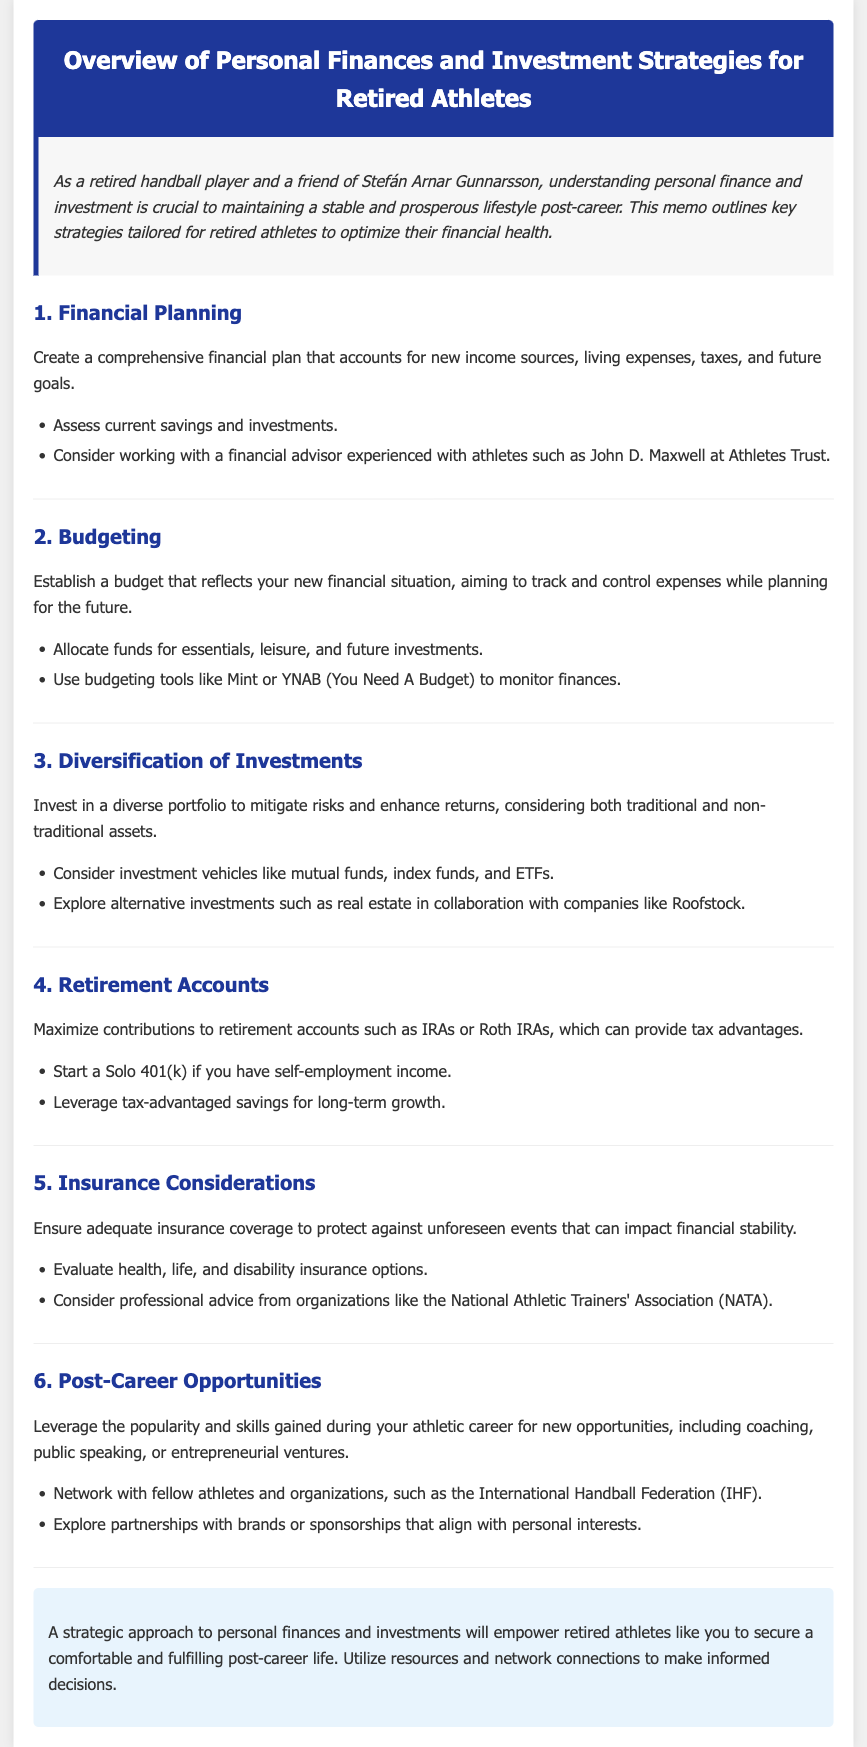What is the first step in financial planning? The first step mentioned in the document for financial planning is to create a comprehensive financial plan that accounts for new income sources, living expenses, taxes, and future goals.
Answer: Create a comprehensive financial plan Who is suggested for financial advice? The document suggests working with a financial advisor experienced with athletes such as John D. Maxwell at Athletes Trust.
Answer: John D. Maxwell Which budgeting tool is mentioned? The document mentions using budgeting tools like Mint or YNAB (You Need A Budget) to monitor finances.
Answer: Mint or YNAB What type of investment accounts should be maximized? The document advises maximizing contributions to retirement accounts such as IRAs or Roth IRAs.
Answer: IRAs or Roth IRAs What type of insurance options should be evaluated? The document states to evaluate health, life, and disability insurance options to ensure adequate coverage.
Answer: Health, life, and disability insurance What kind of post-career opportunities can retired athletes explore? The document suggests leveraging popularity and skills for new opportunities, including coaching, public speaking, or entrepreneurial ventures.
Answer: Coaching, public speaking, or entrepreneurial ventures What is the role of networking according to the document? The document states that networking with fellow athletes and organizations, such as the International Handball Federation (IHF), can provide post-career opportunities.
Answer: Networking How does the document suggest protecting financial stability? The document suggests ensuring adequate insurance coverage to protect against unforeseen events impacting financial stability.
Answer: Adequate insurance coverage What is the conclusion regarding personal finances and investments? The document concludes that a strategic approach to personal finances and investments will empower retired athletes to secure a comfortable post-career life.
Answer: Strategic approach to personal finances 